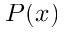<formula> <loc_0><loc_0><loc_500><loc_500>P ( x )</formula> 